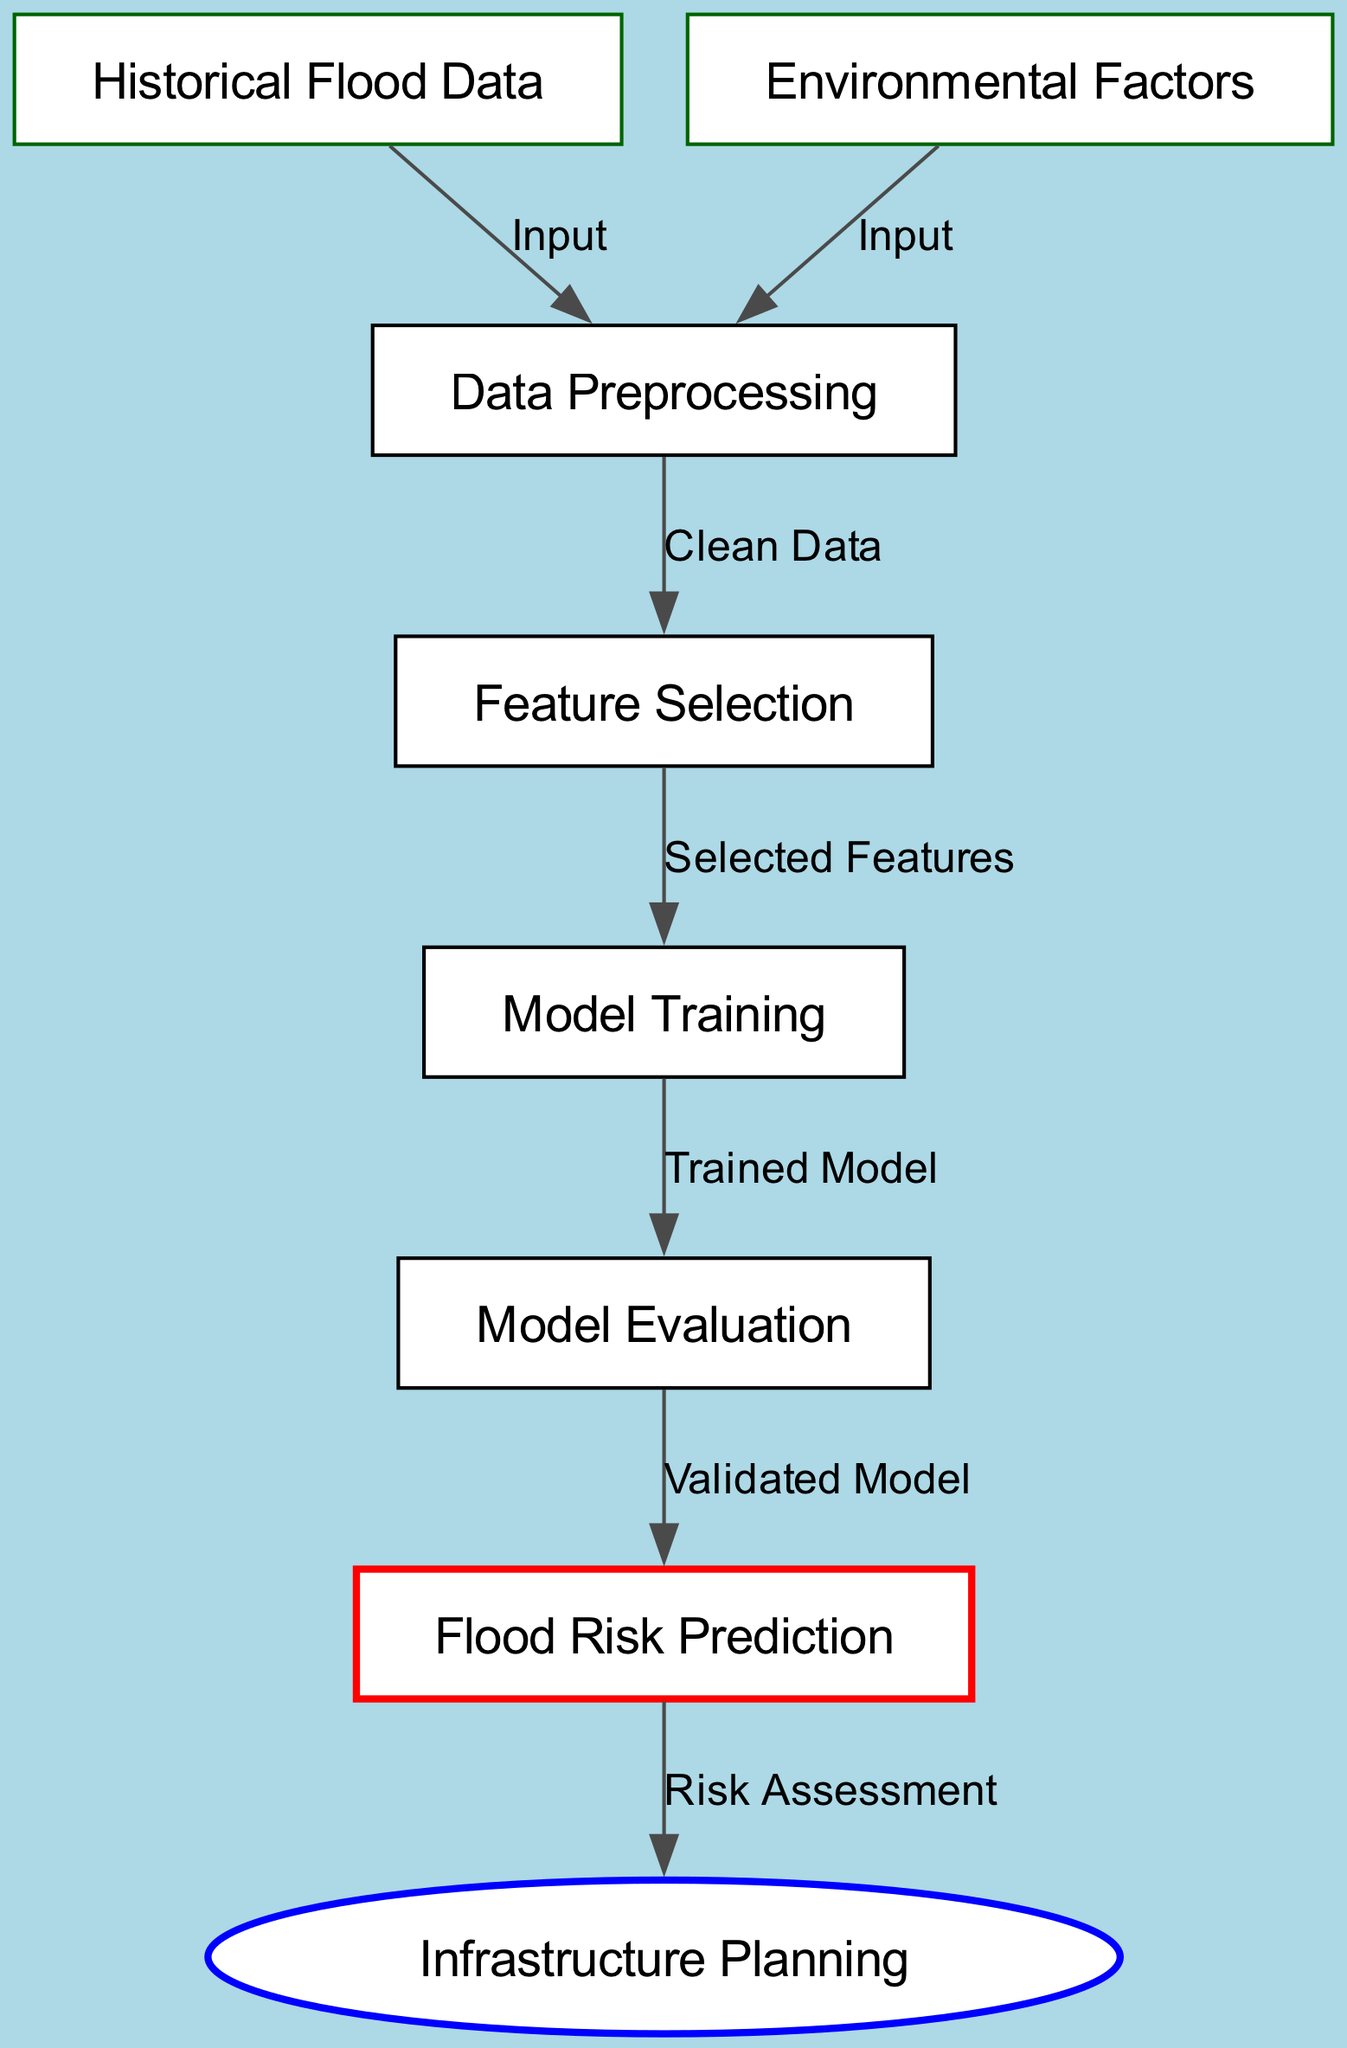What is the first step in the machine learning process? The first step is the "Historical Flood Data" node. The flowchart begins with this data as the initial input needed for the machine learning process.
Answer: Historical Flood Data How many input nodes are there? There are two input nodes: "Historical Flood Data" and "Environmental Factors." These nodes provide the necessary data for preprocessing.
Answer: 2 What kind of data does the "Data Preprocessing" step require? The "Data Preprocessing" step requires input from both "Historical Flood Data" and "Environmental Factors." It combines this data for a thorough cleansing process.
Answer: Clean Data Which node comes after "Model Training"? The node that comes after "Model Training" is "Model Evaluation." This indicates that once the model is trained, it must be evaluated to ensure performance.
Answer: Model Evaluation What results from the "Flood Risk Prediction" step? The result from the "Flood Risk Prediction" step is "Infrastructure Planning." This indicates that the predicted risks lead to plans for infrastructure improvements.
Answer: Infrastructure Planning How many edges are in the diagram? The diagram contains six edges, which illustrate the flow between the nodes in the machine learning process. Each edge represents a connection between two nodes showing the relations.
Answer: 6 What is the final output of the diagram? The final output of the diagram is "Infrastructure Planning," indicating that the prediction of flood risks ultimately informs how infrastructure should be planned accordingly.
Answer: Infrastructure Planning What is the relationship between "Feature Selection" and "Model Training"? The relationship is that "Feature Selection" provides the "Selected Features" as input to "Model Training," which needs these features to develop the predictive model.
Answer: Selected Features What color is the "Flood Risk Prediction" node? The "Flood Risk Prediction" node is colored red, indicating it as a significant point in the process where important predictions are made.
Answer: Red 